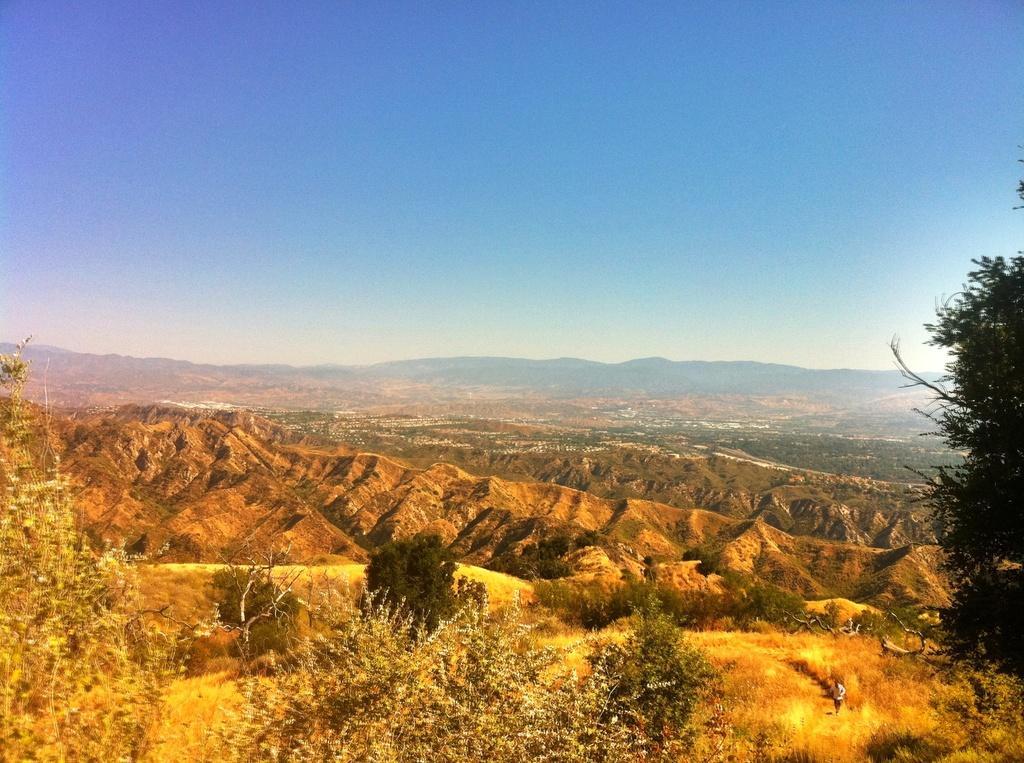Describe this image in one or two sentences. As we can see in the image there are trees, plants, hills and sky. 